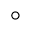Convert formula to latex. <formula><loc_0><loc_0><loc_500><loc_500>^ { \circ }</formula> 